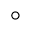Convert formula to latex. <formula><loc_0><loc_0><loc_500><loc_500>^ { \circ }</formula> 